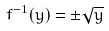Convert formula to latex. <formula><loc_0><loc_0><loc_500><loc_500>f ^ { - 1 } ( y ) = \pm \sqrt { y }</formula> 